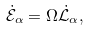Convert formula to latex. <formula><loc_0><loc_0><loc_500><loc_500>\dot { \mathcal { E } } _ { \alpha } = \Omega \dot { \mathcal { L } } _ { \alpha } ,</formula> 